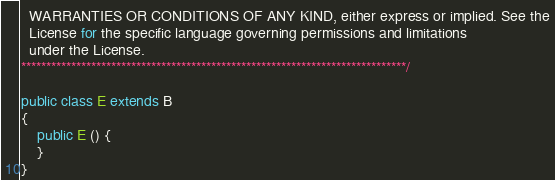Convert code to text. <code><loc_0><loc_0><loc_500><loc_500><_Java_>  WARRANTIES OR CONDITIONS OF ANY KIND, either express or implied. See the
  License for the specific language governing permissions and limitations
  under the License.
*****************************************************************************/

public class E extends B
{
    public E () {
    }
}
</code> 